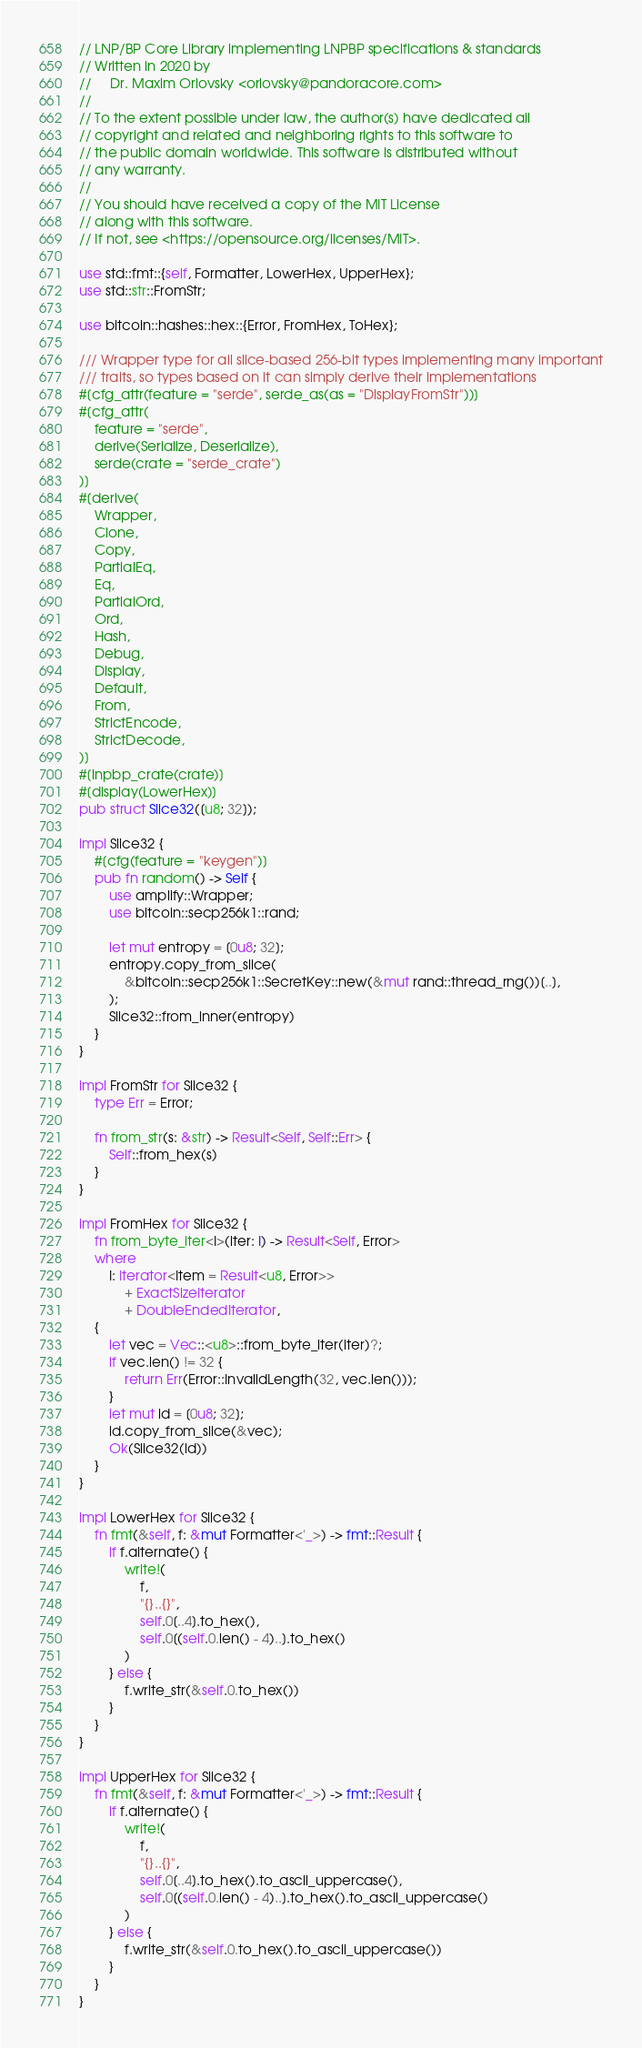<code> <loc_0><loc_0><loc_500><loc_500><_Rust_>// LNP/BP Core Library implementing LNPBP specifications & standards
// Written in 2020 by
//     Dr. Maxim Orlovsky <orlovsky@pandoracore.com>
//
// To the extent possible under law, the author(s) have dedicated all
// copyright and related and neighboring rights to this software to
// the public domain worldwide. This software is distributed without
// any warranty.
//
// You should have received a copy of the MIT License
// along with this software.
// If not, see <https://opensource.org/licenses/MIT>.

use std::fmt::{self, Formatter, LowerHex, UpperHex};
use std::str::FromStr;

use bitcoin::hashes::hex::{Error, FromHex, ToHex};

/// Wrapper type for all slice-based 256-bit types implementing many important
/// traits, so types based on it can simply derive their implementations
#[cfg_attr(feature = "serde", serde_as(as = "DisplayFromStr"))]
#[cfg_attr(
    feature = "serde",
    derive(Serialize, Deserialize),
    serde(crate = "serde_crate")
)]
#[derive(
    Wrapper,
    Clone,
    Copy,
    PartialEq,
    Eq,
    PartialOrd,
    Ord,
    Hash,
    Debug,
    Display,
    Default,
    From,
    StrictEncode,
    StrictDecode,
)]
#[lnpbp_crate(crate)]
#[display(LowerHex)]
pub struct Slice32([u8; 32]);

impl Slice32 {
    #[cfg(feature = "keygen")]
    pub fn random() -> Self {
        use amplify::Wrapper;
        use bitcoin::secp256k1::rand;

        let mut entropy = [0u8; 32];
        entropy.copy_from_slice(
            &bitcoin::secp256k1::SecretKey::new(&mut rand::thread_rng())[..],
        );
        Slice32::from_inner(entropy)
    }
}

impl FromStr for Slice32 {
    type Err = Error;

    fn from_str(s: &str) -> Result<Self, Self::Err> {
        Self::from_hex(s)
    }
}

impl FromHex for Slice32 {
    fn from_byte_iter<I>(iter: I) -> Result<Self, Error>
    where
        I: Iterator<Item = Result<u8, Error>>
            + ExactSizeIterator
            + DoubleEndedIterator,
    {
        let vec = Vec::<u8>::from_byte_iter(iter)?;
        if vec.len() != 32 {
            return Err(Error::InvalidLength(32, vec.len()));
        }
        let mut id = [0u8; 32];
        id.copy_from_slice(&vec);
        Ok(Slice32(id))
    }
}

impl LowerHex for Slice32 {
    fn fmt(&self, f: &mut Formatter<'_>) -> fmt::Result {
        if f.alternate() {
            write!(
                f,
                "{}..{}",
                self.0[..4].to_hex(),
                self.0[(self.0.len() - 4)..].to_hex()
            )
        } else {
            f.write_str(&self.0.to_hex())
        }
    }
}

impl UpperHex for Slice32 {
    fn fmt(&self, f: &mut Formatter<'_>) -> fmt::Result {
        if f.alternate() {
            write!(
                f,
                "{}..{}",
                self.0[..4].to_hex().to_ascii_uppercase(),
                self.0[(self.0.len() - 4)..].to_hex().to_ascii_uppercase()
            )
        } else {
            f.write_str(&self.0.to_hex().to_ascii_uppercase())
        }
    }
}
</code> 